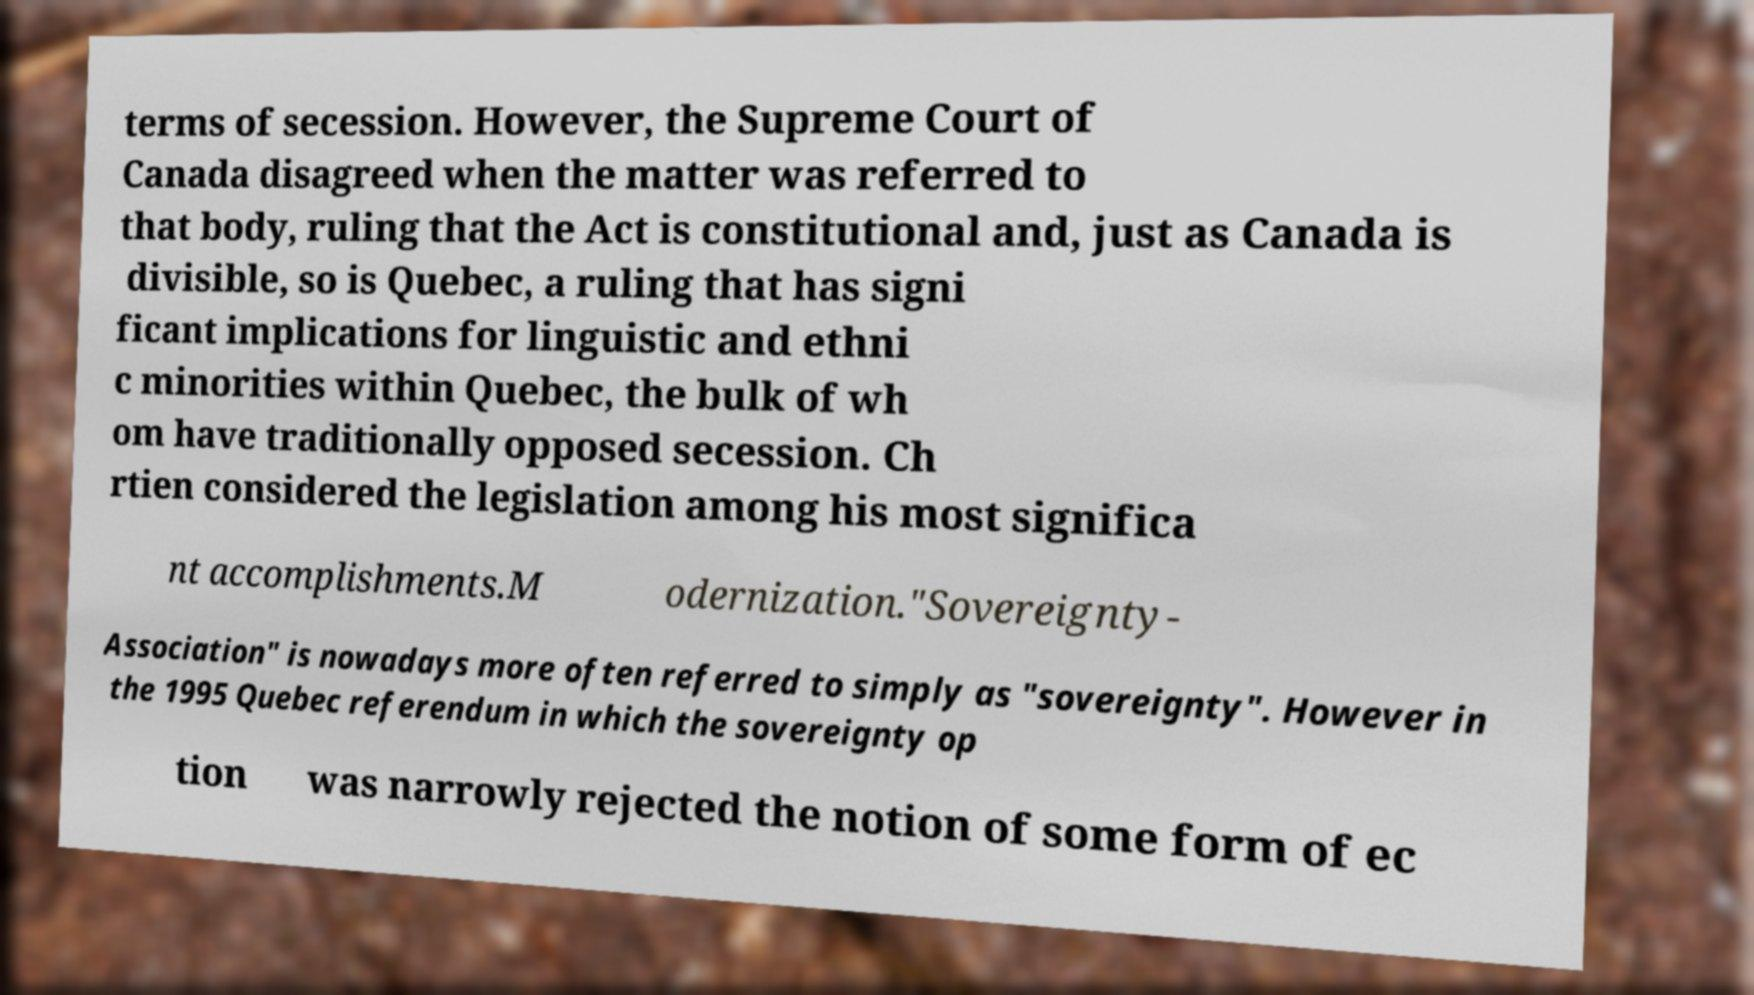Can you accurately transcribe the text from the provided image for me? terms of secession. However, the Supreme Court of Canada disagreed when the matter was referred to that body, ruling that the Act is constitutional and, just as Canada is divisible, so is Quebec, a ruling that has signi ficant implications for linguistic and ethni c minorities within Quebec, the bulk of wh om have traditionally opposed secession. Ch rtien considered the legislation among his most significa nt accomplishments.M odernization."Sovereignty- Association" is nowadays more often referred to simply as "sovereignty". However in the 1995 Quebec referendum in which the sovereignty op tion was narrowly rejected the notion of some form of ec 